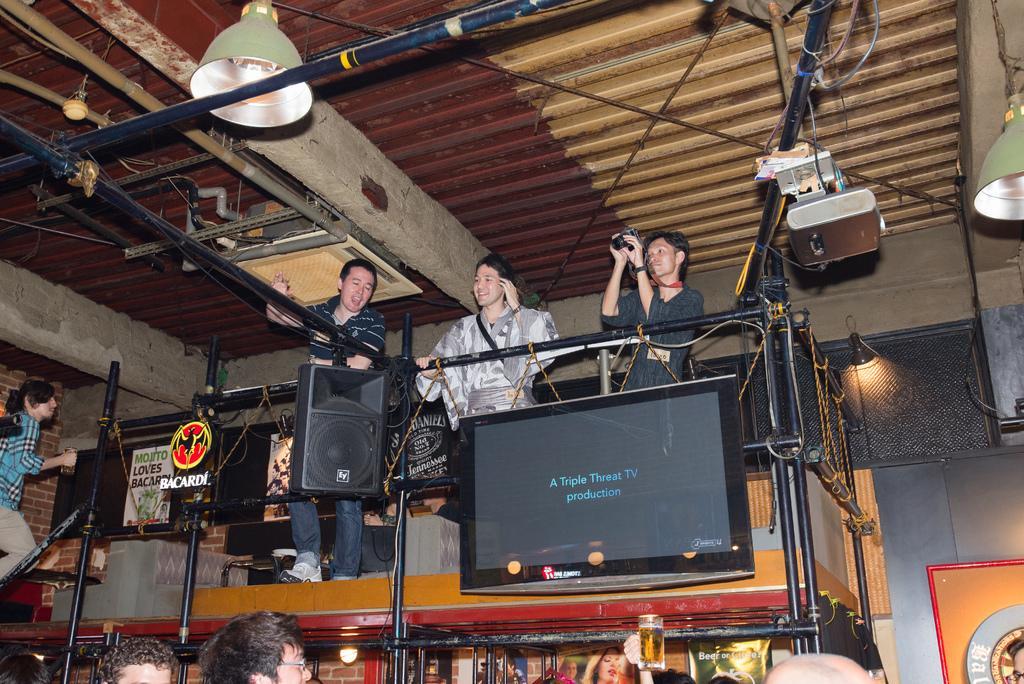Can you describe this image briefly? In this image three people are standing on the stage. And holding some object. There are few lamps and a projector is hanged to the roof. There are few people are standing below the stage. There is a loudspeaker and a television in the image. 